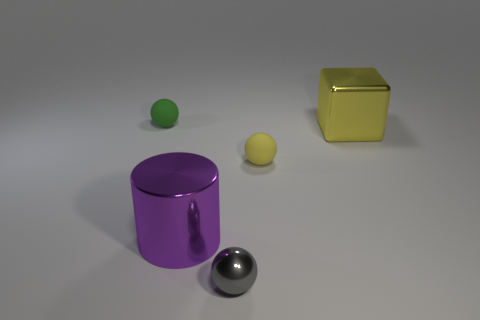Add 4 big things. How many objects exist? 9 Subtract all spheres. How many objects are left? 2 Subtract 0 red cylinders. How many objects are left? 5 Subtract all large blocks. Subtract all green rubber cubes. How many objects are left? 4 Add 3 yellow shiny things. How many yellow shiny things are left? 4 Add 4 yellow shiny blocks. How many yellow shiny blocks exist? 5 